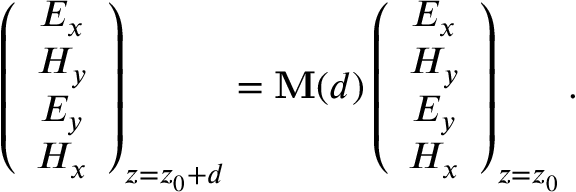Convert formula to latex. <formula><loc_0><loc_0><loc_500><loc_500>\left ( \begin{array} { c } { E _ { x } } \\ { H _ { y } } \\ { E _ { y } } \\ { H _ { x } } \end{array} \right ) _ { z = z _ { 0 } + d } = \mathbf M ( d ) \left ( \begin{array} { c } { E _ { x } } \\ { H _ { y } } \\ { E _ { y } } \\ { H _ { x } } \end{array} \right ) _ { z = z _ { 0 } } .</formula> 